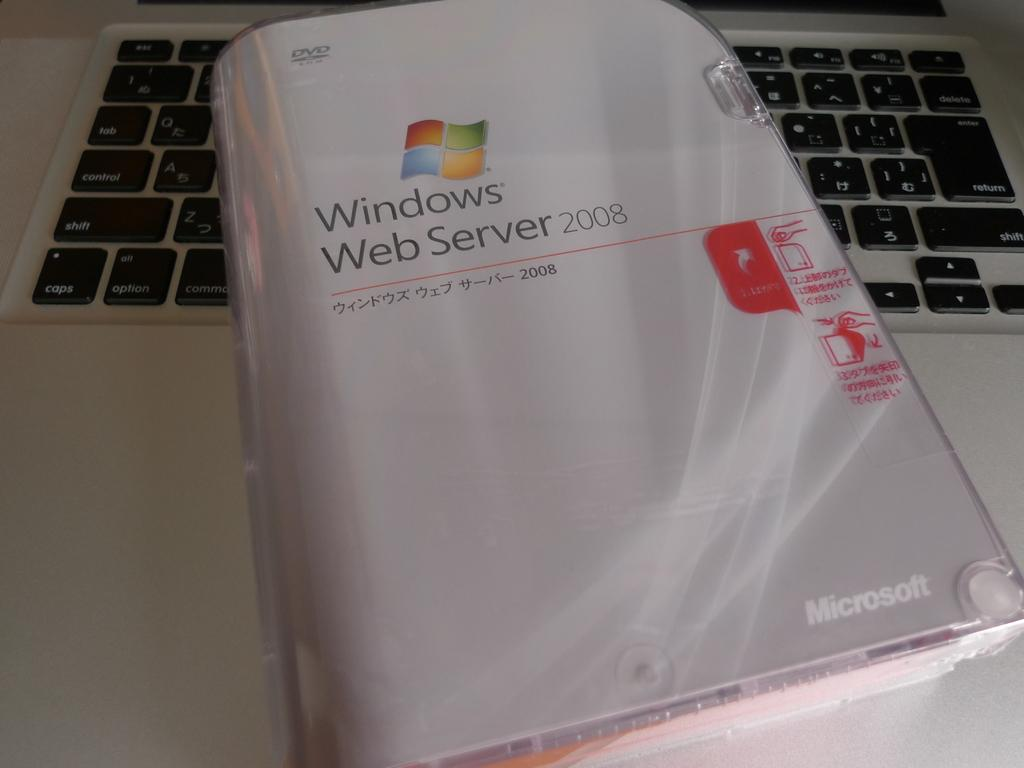<image>
Summarize the visual content of the image. A DVD titled Windows Web Server is dated 2008 and has opening instructions on the side. 